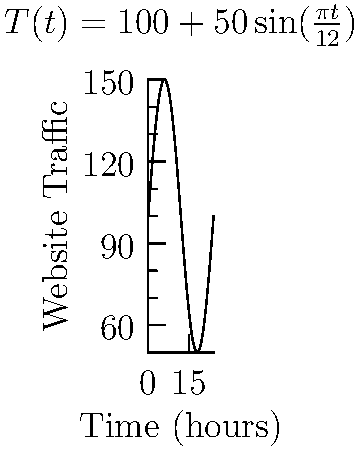As a website administrator, you're analyzing traffic patterns using the function $T(t) = 100 + 50\sin(\frac{\pi t}{12})$, where $T$ represents the number of active users and $t$ is the time in hours. At what time during the first 24 hours is the rate of change in website traffic the highest? Express your answer in hours. To find the time when the rate of change is highest, we need to follow these steps:

1) The rate of change is represented by the derivative of $T(t)$. Let's call it $T'(t)$.

2) Calculate $T'(t)$:
   $T'(t) = 50 \cdot \frac{\pi}{12} \cos(\frac{\pi t}{12})$

3) The rate of change is highest when $T'(t)$ is at its maximum value. This occurs when $\cos(\frac{\pi t}{12})$ = 1.

4) Solve for $t$ when $\cos(\frac{\pi t}{12}) = 1$:
   $\frac{\pi t}{12} = 2\pi n$, where $n$ is an integer

5) Solving for $t$:
   $t = 24n$, where $n$ is an integer

6) Within the first 24 hours, this occurs when $n = 0$, so $t = 0$.

Therefore, the rate of change is highest at $t = 0$ hours, which corresponds to the beginning of the time period.
Answer: 0 hours 